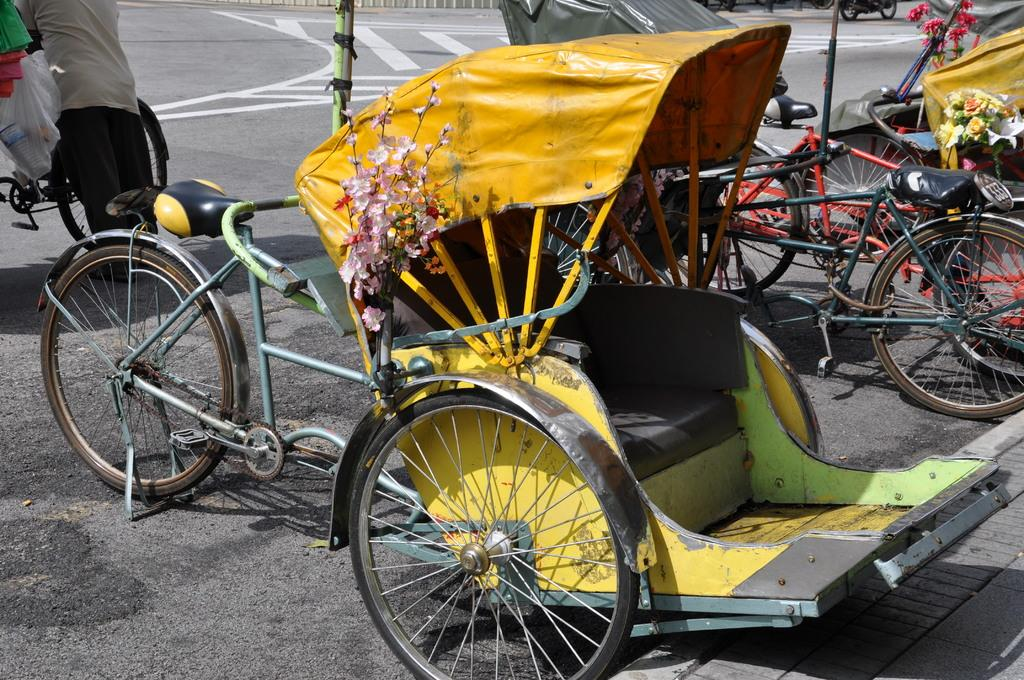What type of vehicles are present in the image? There are cycles and rickshaws in the image. Can you describe the person in the image? There is a person on the left side of the image. What type of thrill can be experienced by riding the cycles in the image? The image does not convey any information about the experience of riding the cycles, so it is not possible to determine the type of thrill that might be experienced. 